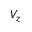Convert formula to latex. <formula><loc_0><loc_0><loc_500><loc_500>V _ { z }</formula> 